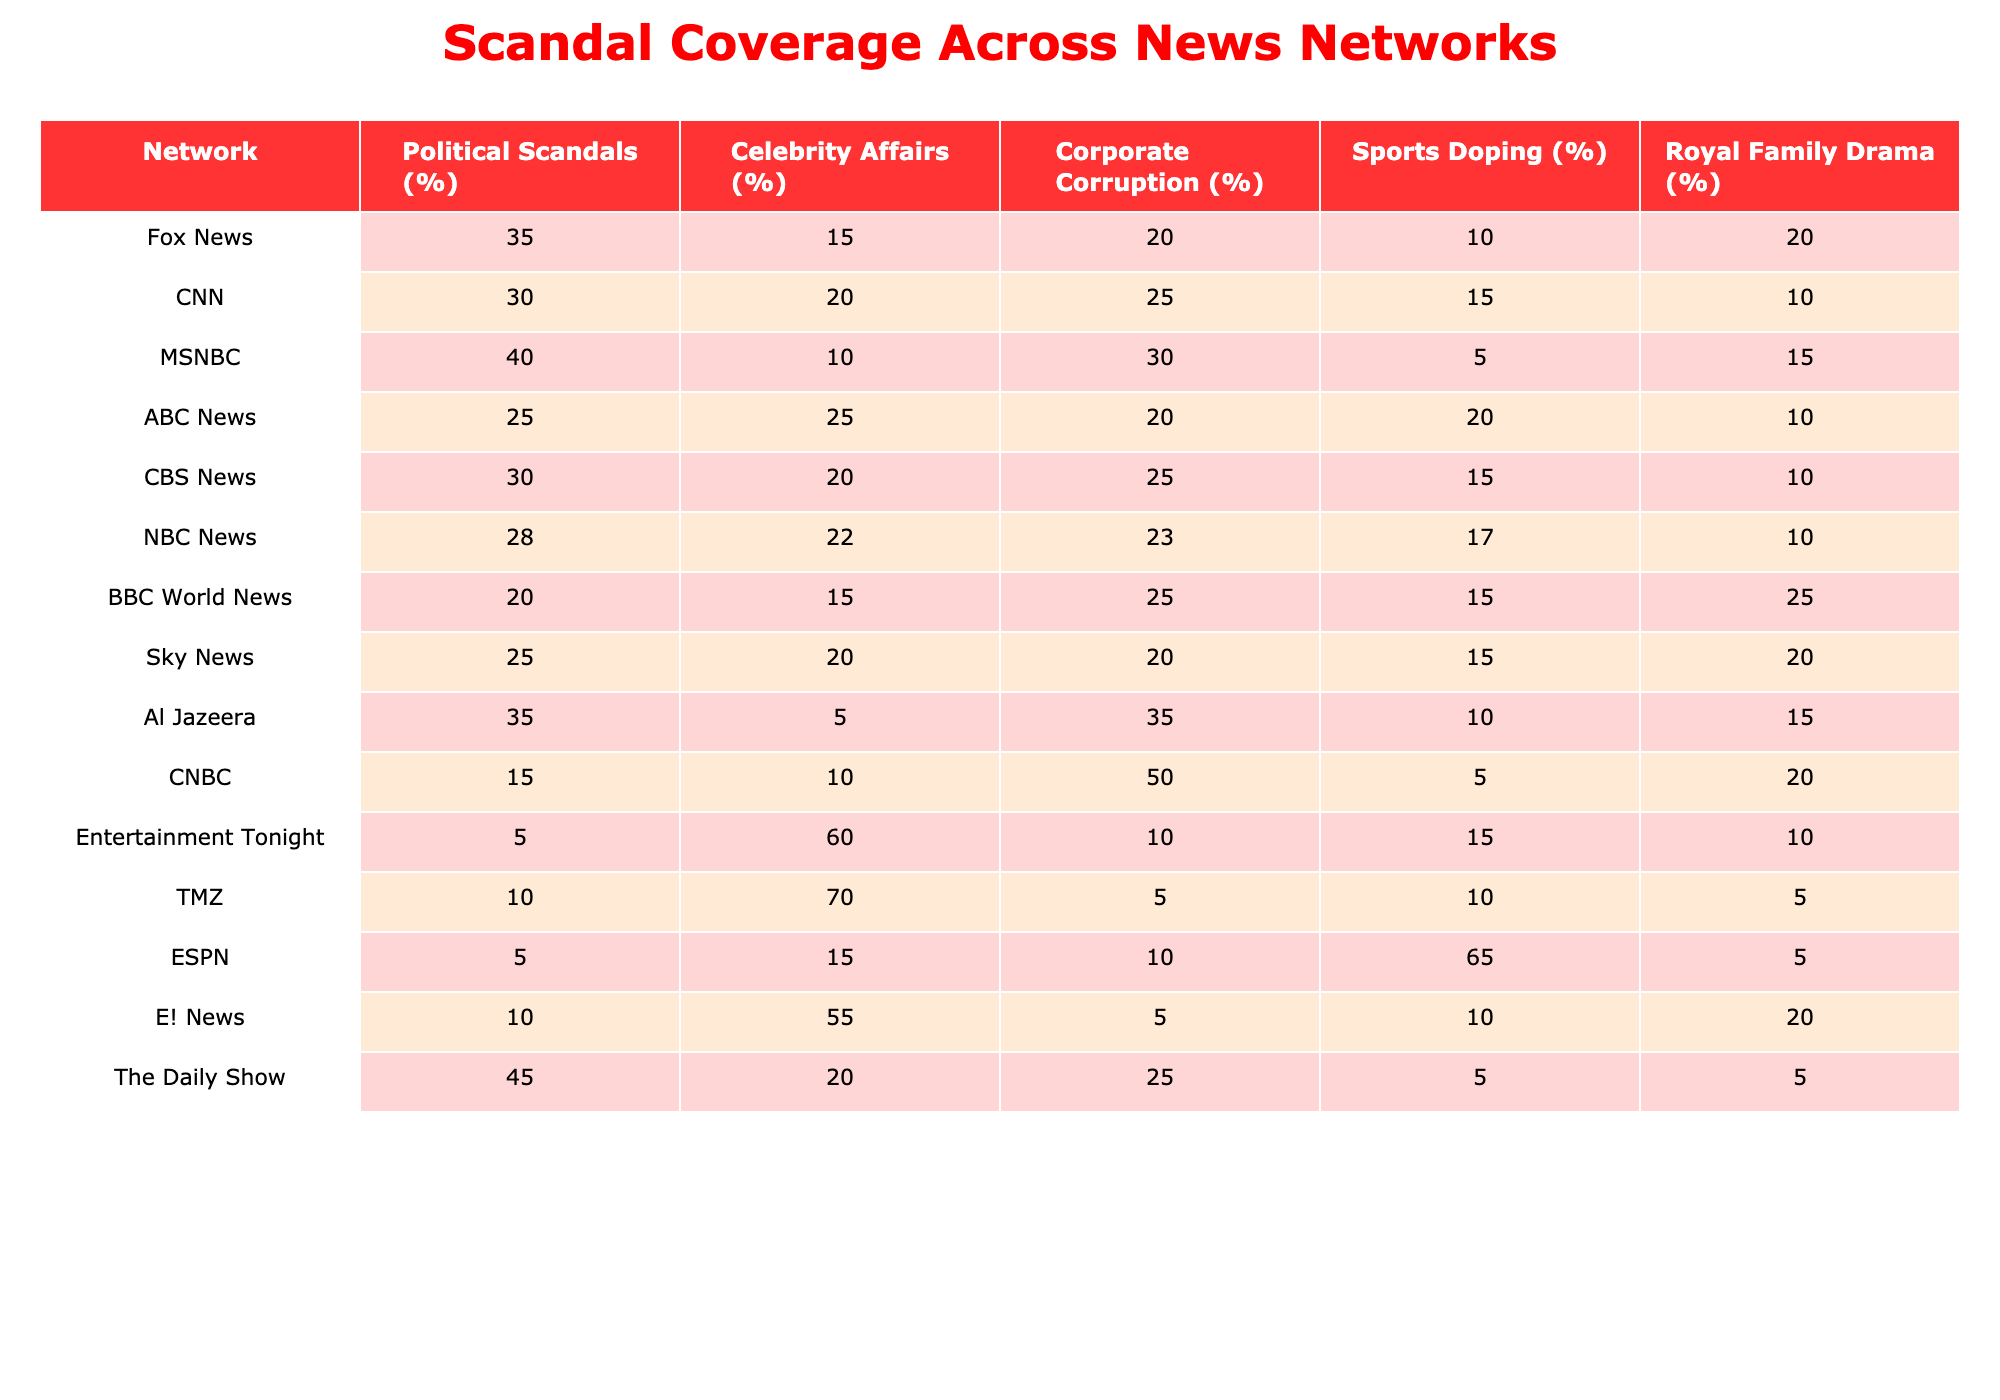What percentage of Fox News coverage is devoted to Political Scandals? According to the table, Fox News devotes 35% of its coverage to Political Scandals.
Answer: 35% Which network gives the highest percentage to Celebrity Affairs? The table shows that TMZ devotes 70% of its coverage to Celebrity Affairs, the highest among all networks.
Answer: TMZ What is the average percentage of coverage for Corporate Corruption across all networks? To find the average, sum the percentages (20 + 25 + 30 + 20 + 25 + 23 + 25 + 20 + 35 + 50 + 10 + 5 + 10) which equals  330. There are 13 networks, so divide 330 by 13 to get approximately 25.38.
Answer: 25.38 Is there any network that allocates 50% or more to Corporate Corruption? Looking at the table, CNBC is the only network allocating 50% to Corporate Corruption, hence the statement is true.
Answer: Yes What is the difference in percentage between the highest and lowest coverage for Sports Doping? ESPN has the highest coverage at 65% while MSNBC has the lowest at 5%. The difference is 65 - 5 = 60%.
Answer: 60% Which network treats Royal Family Drama with the least percentage of coverage? Both CNN and CBS News allocate 10% to Royal Family Drama, which is the least coverage noted in the table.
Answer: CNN and CBS News How does the coverage of Political Scandals by MSNBC compare to that of ABC News? MSNBC allocates 40% to Political Scandals while ABC News allocates 25%. The difference is 40 - 25 = 15%. Thus, MSNBC covers Political Scandals 15% more than ABC News.
Answer: 15% What is the cumulative percentage of coverage for Celebrity Affairs across the top three networks? The top three networks based on coverage percentage for Celebrity Affairs are TMZ (70%), E! News (55%), and Entertainment Tonight (60%). Adding these gives 70 + 55 + 60 = 185%.
Answer: 185% Which network has a balanced coverage distribution (close percentages) across all categories? ABC News has somewhat balanced coverage with percentages of 25% for Celebrity Affairs, 20% for Corporate Corruption, 20% for Sports Doping, and 10% for Royal Family Drama. This indicates a fair distribution.
Answer: ABC News What percentage of coverage does Al Jazeera allocate to Political Scandals compared to BBC World News? Al Jazeera allocates 35% and BBC World News allocates 20% to Political Scandals. Thus, Al Jazeera allocates 15% more than BBC World News (35 - 20 = 15).
Answer: 15% Is it true that all networks provide at least 10% coverage for Sports Doping? By reviewing the table, ESPN stands out with 65%, while CNBC has only 5%. This makes the statement false since CNBC's coverage is below 10%.
Answer: No 